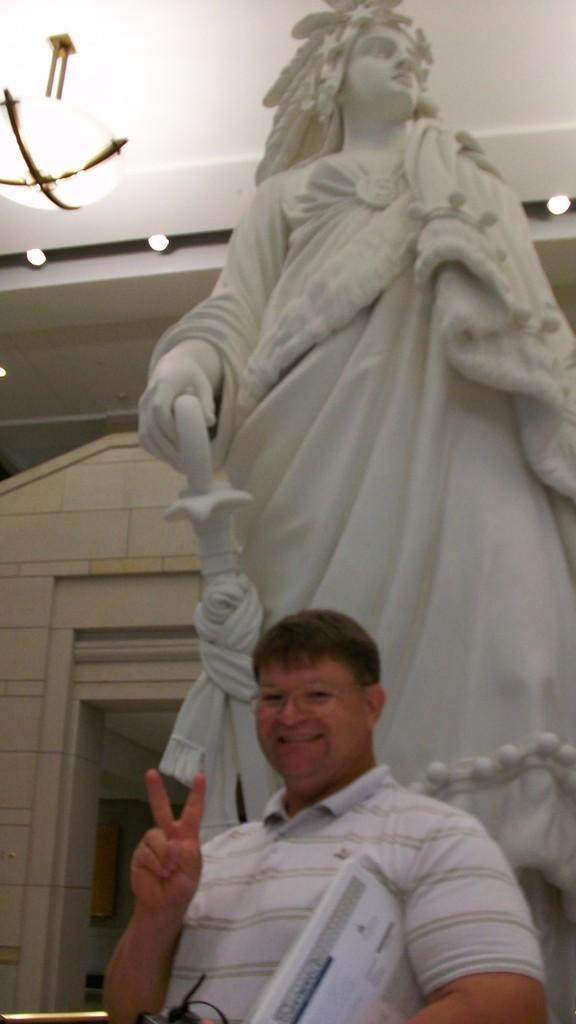Please provide a concise description of this image. In this image I can see the white color statue. In-front of the statue I can see the white color dress and also he is holding the papers. In the back I can see many lights and also the white wall. 